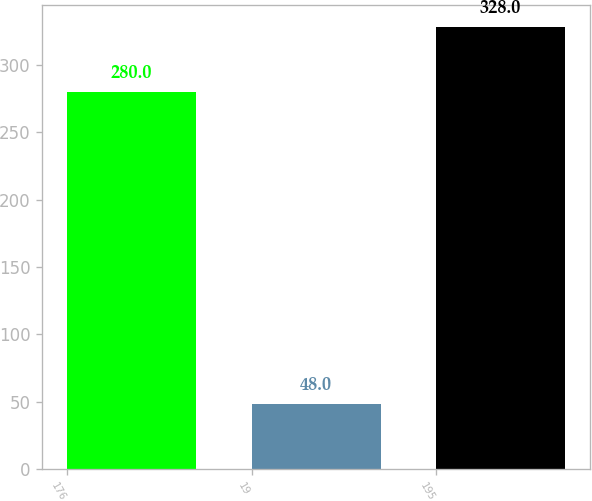Convert chart. <chart><loc_0><loc_0><loc_500><loc_500><bar_chart><fcel>176<fcel>19<fcel>195<nl><fcel>280<fcel>48<fcel>328<nl></chart> 